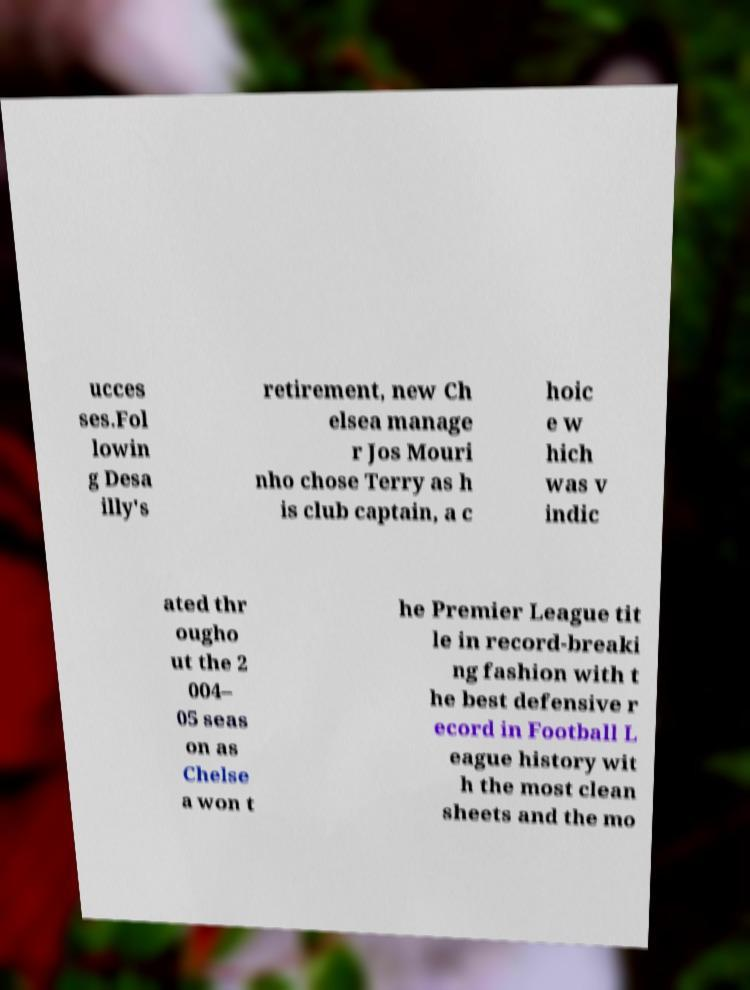Can you accurately transcribe the text from the provided image for me? ucces ses.Fol lowin g Desa illy's retirement, new Ch elsea manage r Jos Mouri nho chose Terry as h is club captain, a c hoic e w hich was v indic ated thr ougho ut the 2 004– 05 seas on as Chelse a won t he Premier League tit le in record-breaki ng fashion with t he best defensive r ecord in Football L eague history wit h the most clean sheets and the mo 